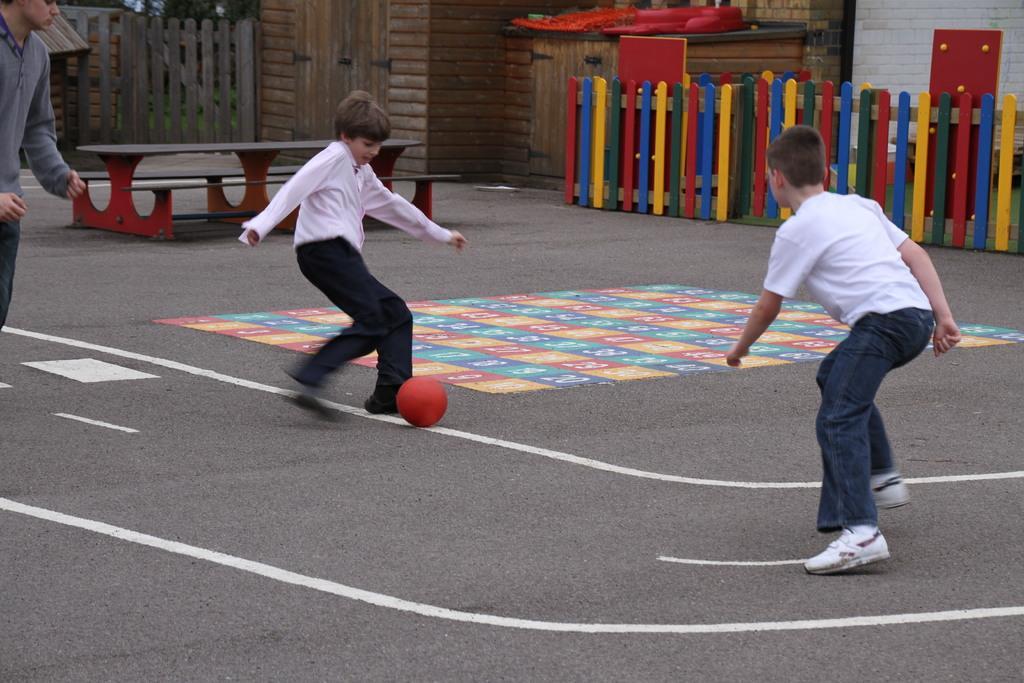In one or two sentences, can you explain what this image depicts? There are 2 kids playing with ball. In the background there is fence,wall and a table. 